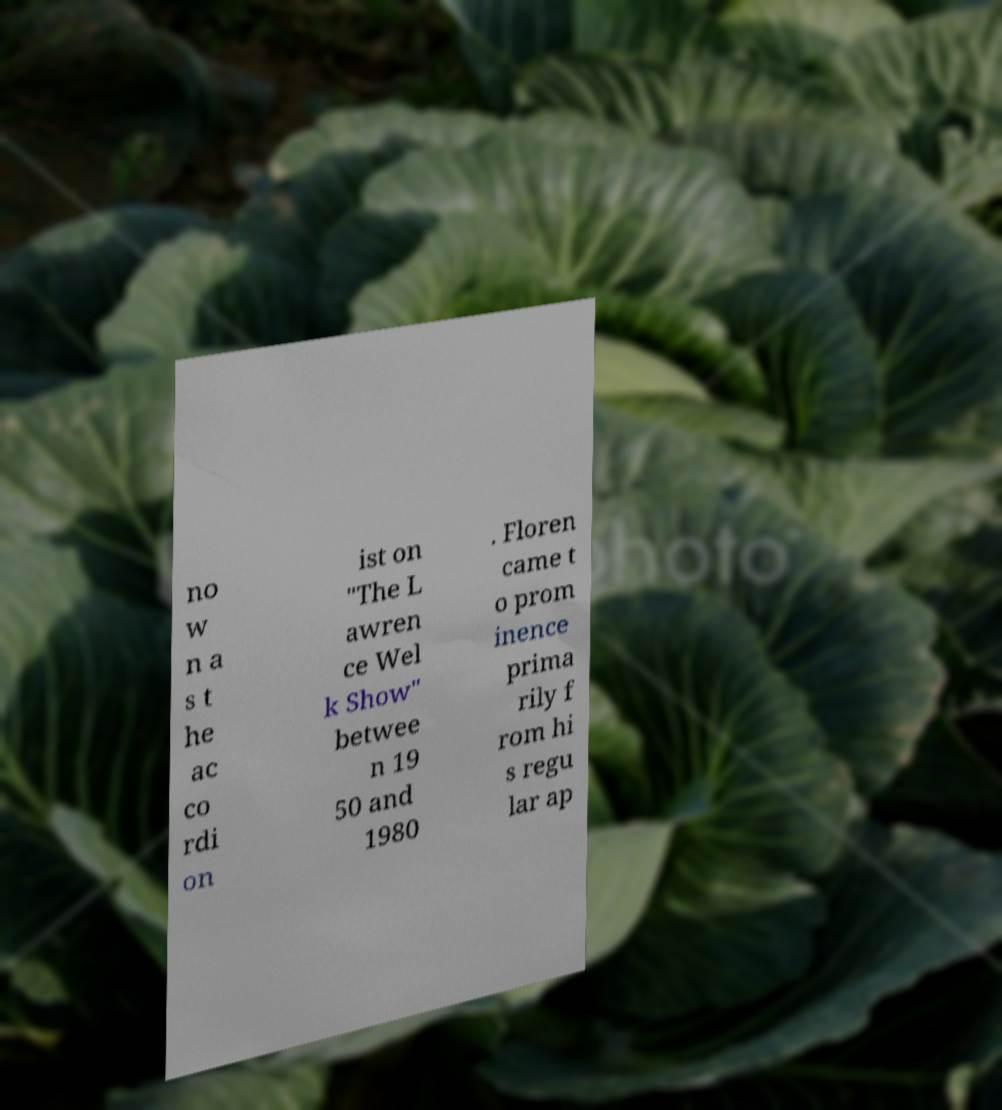I need the written content from this picture converted into text. Can you do that? no w n a s t he ac co rdi on ist on "The L awren ce Wel k Show" betwee n 19 50 and 1980 . Floren came t o prom inence prima rily f rom hi s regu lar ap 